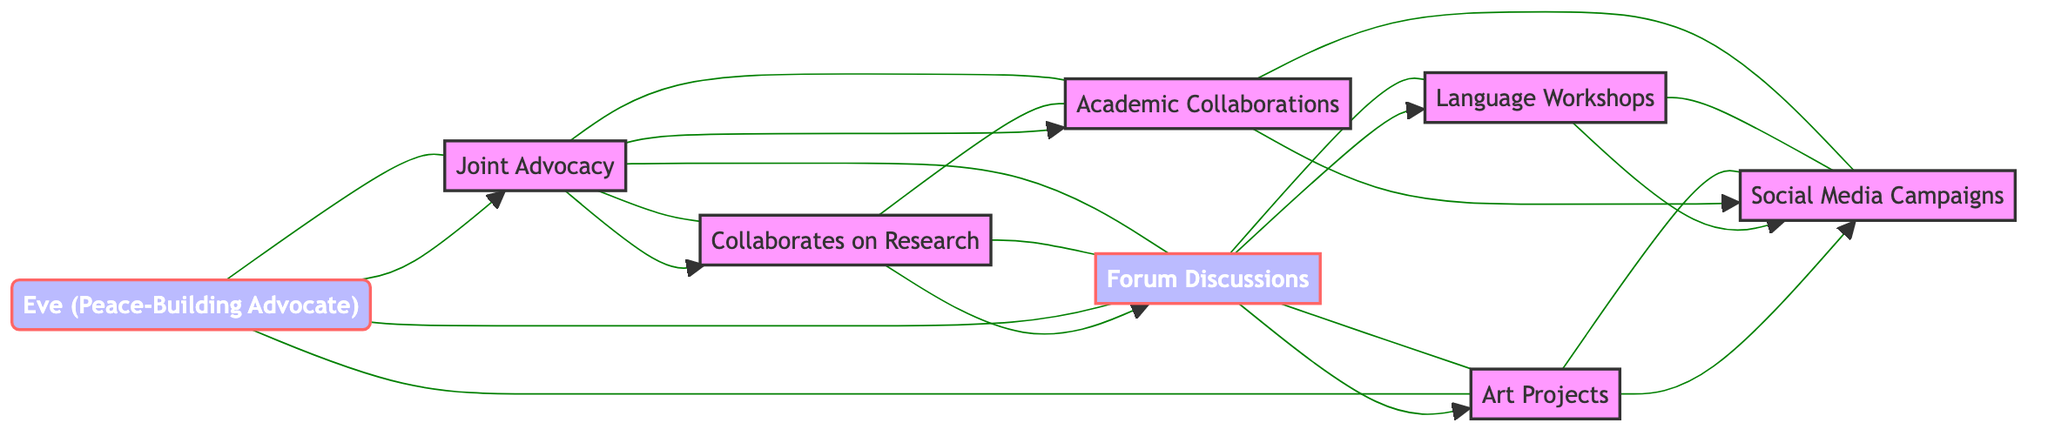What is the total number of nodes in the graph? The diagram lists eight individuals as nodes: Alice, Bob, Clara, David, Eve, Finn, Grace, and Heidi. This count includes everyone shown in the graph without any duplicates.
Answer: 8 Which two individuals are connected by the label "Collaborates on Research"? The edge labeled "Collaborates on Research" connects Alice and Bob. The relationship is explicitly mentioned next to the drawn edge between these two nodes in the diagram.
Answer: Alice and Bob How many edges connect to David? David has edges connecting to Alice, Bob, Finn, and Grace, making for a total of four edges. Counting each connection shows how many individuals interact with David in various capacities.
Answer: 4 Who collaborates with Clara on "Feature Articles"? Clara is connected to Heidi through the edge labeled "Feature Articles." This relationship indicates that Clara's work on this topic involves Heidi.
Answer: Heidi Which two individuals share a connection through "Art for Peace Events"? David and Grace are connected by the edge labeled "Art for Peace Events." This label shows their collaboration in organizing those specific events, as noted next to the edge.
Answer: David and Grace Is there a direct connection between Eve and Finn? There is no edge between Eve and Finn in the diagram, which indicates that they do not have a direct collaboration or relationship based on the provided connections. Thus, the answer is based on the absence of an edge.
Answer: No Which individual is connected to the most people? David connects to Alice, Bob, Finn, and Grace, giving him a total of four connections. Counting the number of edges each individual has leads to this conclusion about David's networking within the group.
Answer: David What type of connection does Eve have with Alice? Eve and Alice are connected through the label "Joint Advocacy." This relationship indicates they work together specifically in the area of advocacy for peace, as represented in the graph.
Answer: Joint Advocacy 